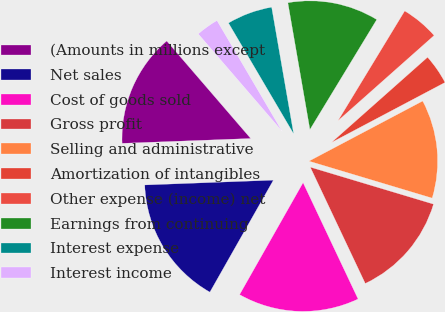Convert chart to OTSL. <chart><loc_0><loc_0><loc_500><loc_500><pie_chart><fcel>(Amounts in millions except<fcel>Net sales<fcel>Cost of goods sold<fcel>Gross profit<fcel>Selling and administrative<fcel>Amortization of intangibles<fcel>Other expense (income) net<fcel>Earnings from continuing<fcel>Interest expense<fcel>Interest income<nl><fcel>14.28%<fcel>16.19%<fcel>15.24%<fcel>13.33%<fcel>12.38%<fcel>3.81%<fcel>4.76%<fcel>11.43%<fcel>5.72%<fcel>2.86%<nl></chart> 